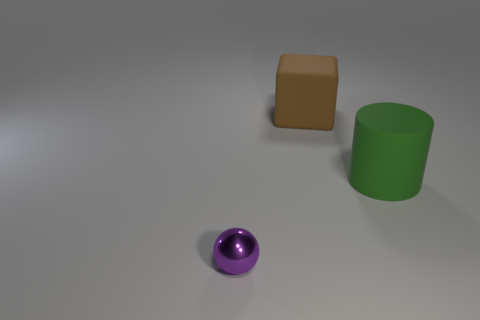Are there any other things that have the same size as the shiny ball?
Your response must be concise. No. There is a brown block that is made of the same material as the big green cylinder; what size is it?
Make the answer very short. Large. How many big green cylinders are behind the large matte object that is in front of the big brown block?
Make the answer very short. 0. How many tiny purple objects are behind the small purple metal object?
Make the answer very short. 0. What color is the big thing right of the big rubber object behind the rubber thing that is in front of the large brown matte cube?
Ensure brevity in your answer.  Green. There is a sphere on the left side of the cylinder; is it the same color as the matte object in front of the matte cube?
Give a very brief answer. No. What is the shape of the object that is on the right side of the big thing behind the big cylinder?
Make the answer very short. Cylinder. Are there any purple metallic spheres that have the same size as the green object?
Offer a very short reply. No. What number of other large green things have the same shape as the large green object?
Ensure brevity in your answer.  0. Are there the same number of tiny purple shiny things that are in front of the purple ball and green matte objects that are left of the cylinder?
Give a very brief answer. Yes. 